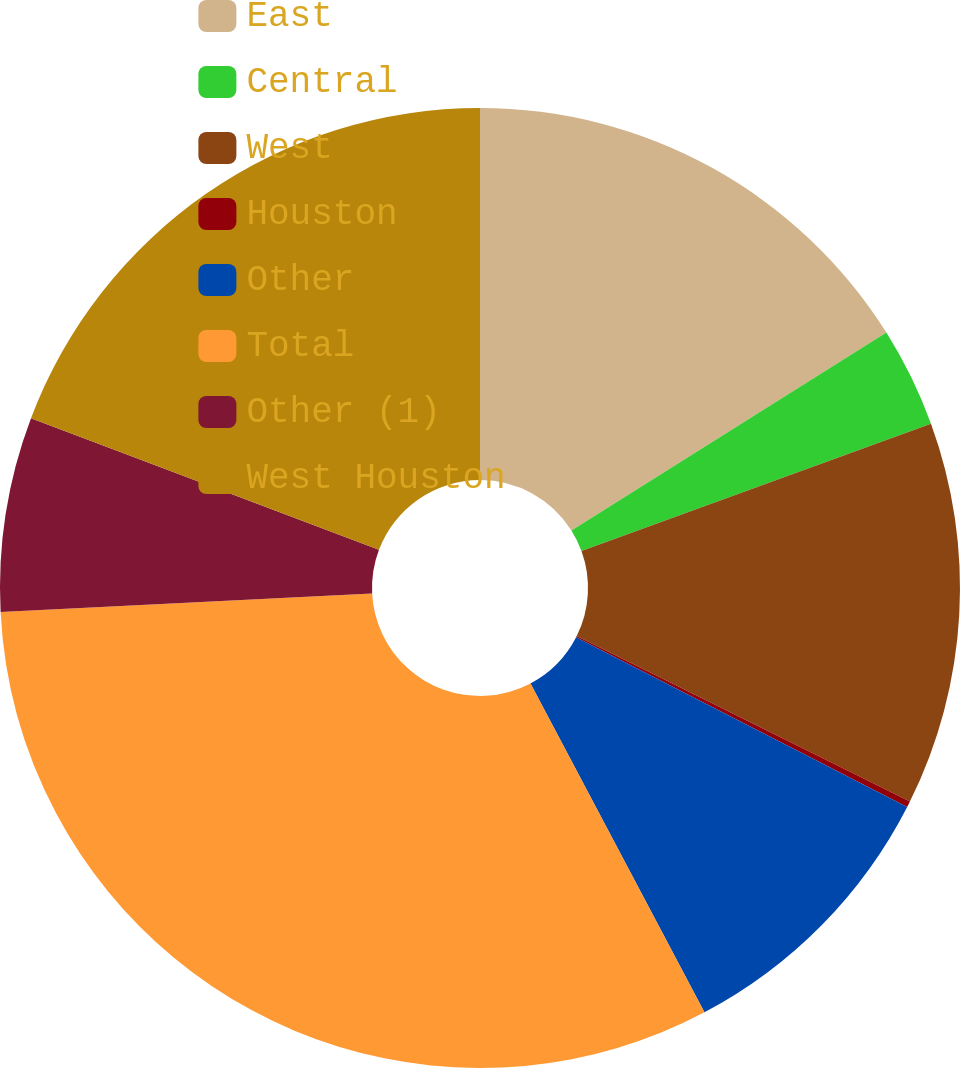Convert chart. <chart><loc_0><loc_0><loc_500><loc_500><pie_chart><fcel>East<fcel>Central<fcel>West<fcel>Houston<fcel>Other<fcel>Total<fcel>Other (1)<fcel>West Houston<nl><fcel>16.07%<fcel>3.37%<fcel>12.9%<fcel>0.2%<fcel>9.72%<fcel>31.95%<fcel>6.55%<fcel>19.25%<nl></chart> 